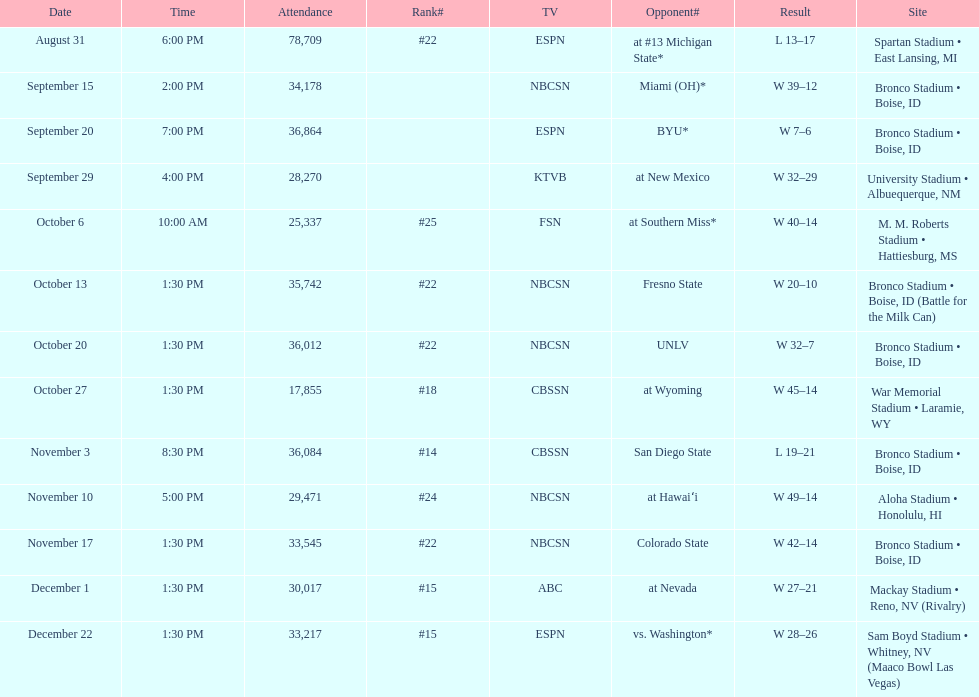Did the broncos on september 29th win by less than 5 points? Yes. 